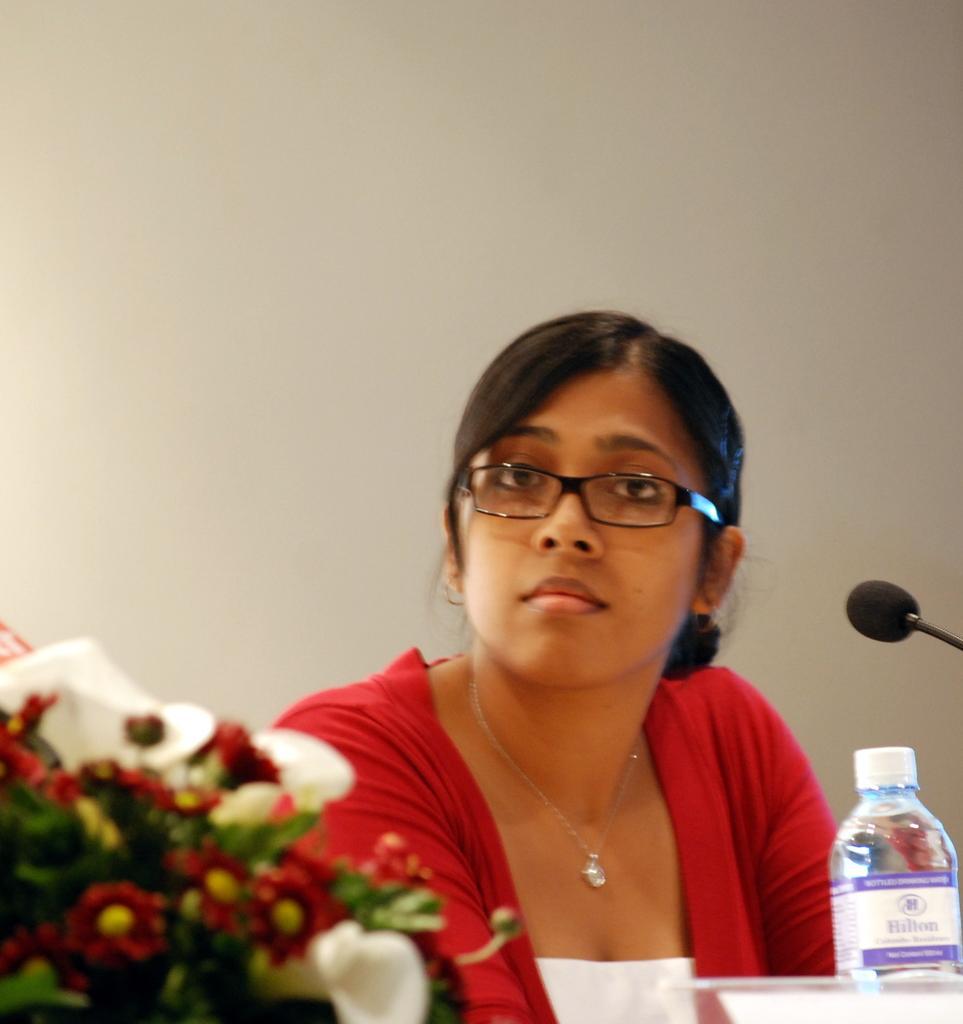Can you describe this image briefly? In this Picture we can see the a women wearing red color jacket with pearl pendant and specs is sitting on the chair and giving the pose into the camera. In front we can see the water bottle , microphone and flower bookey. 